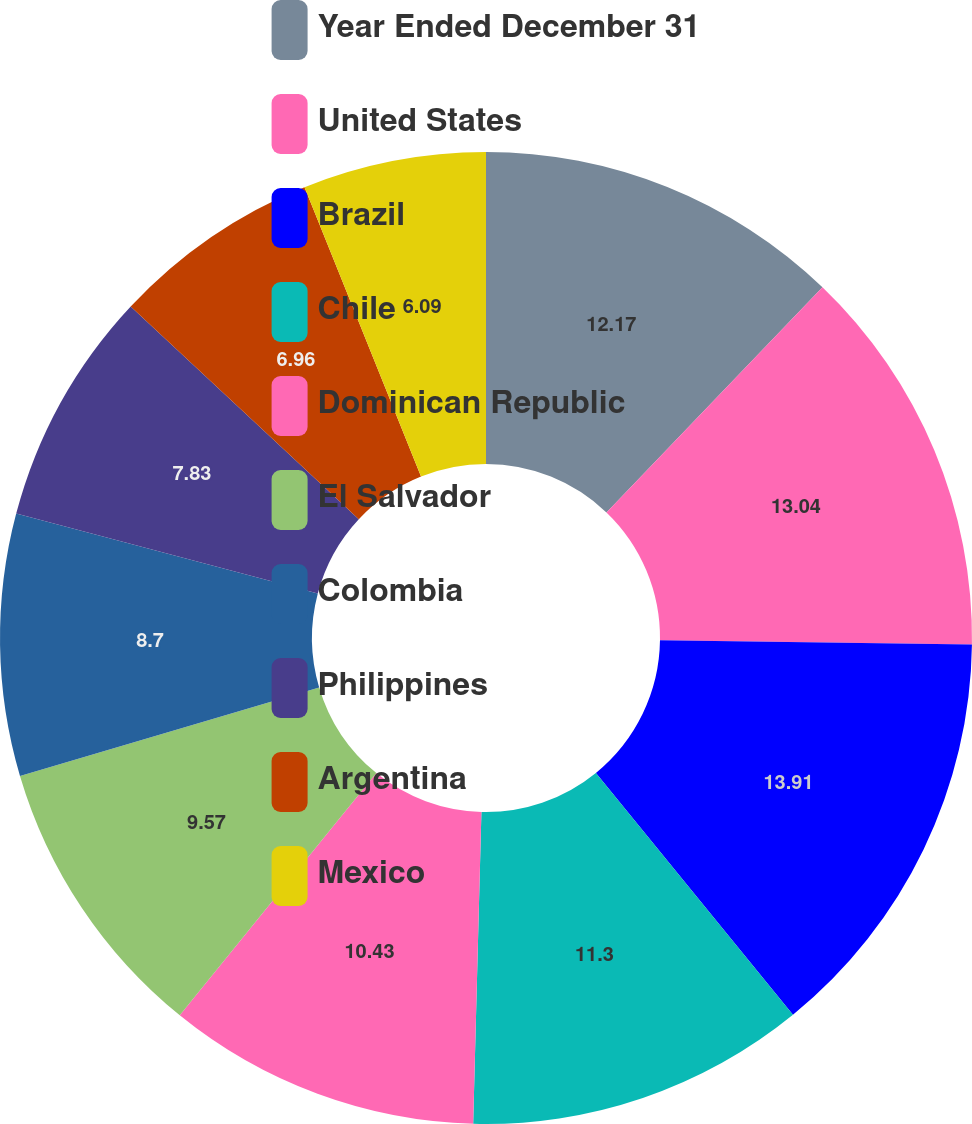Convert chart. <chart><loc_0><loc_0><loc_500><loc_500><pie_chart><fcel>Year Ended December 31<fcel>United States<fcel>Brazil<fcel>Chile<fcel>Dominican Republic<fcel>El Salvador<fcel>Colombia<fcel>Philippines<fcel>Argentina<fcel>Mexico<nl><fcel>12.17%<fcel>13.04%<fcel>13.91%<fcel>11.3%<fcel>10.43%<fcel>9.57%<fcel>8.7%<fcel>7.83%<fcel>6.96%<fcel>6.09%<nl></chart> 